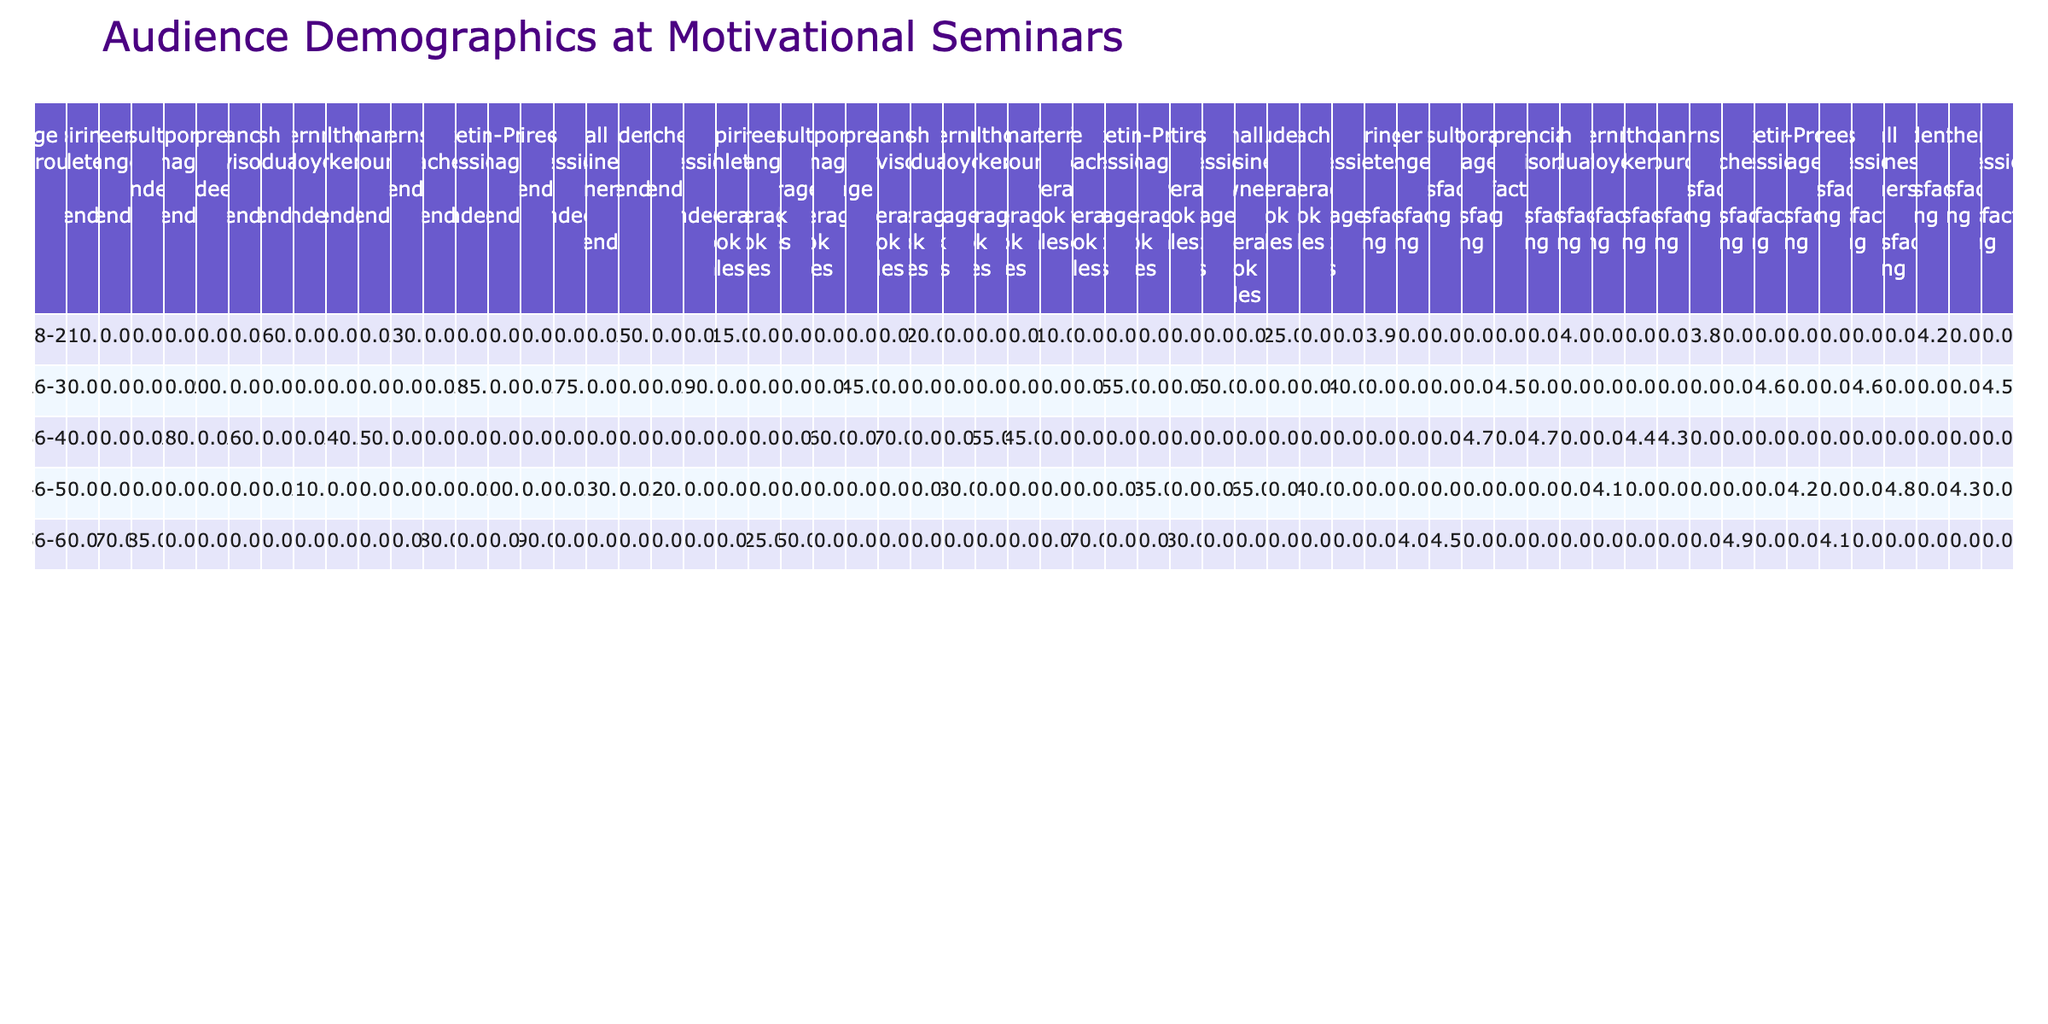What is the satisfaction rating of Corporate Managers? The table shows that Corporate Managers have a satisfaction rating of 4.7.
Answer: 4.7 Which age group has the highest average book sales? Looking at the average book sales for each age group, the 46-55 age group has the highest average book sales at 65.
Answer: 46-55 How many attendees were there for Entrepreneurs in San Francisco? The table indicates that there were 200 attendees for Entrepreneurs in San Francisco.
Answer: 200 Is the average book sales for Tech Professionals higher than that of Life Coaches? Tech Professionals have an average book sales of 40 while Life Coaches have 70. Since 40 is less than 70, the answer is no.
Answer: No What is the total number of attendees for the 26-35 age group across all professions? Adding the attendees: 200 (Entrepreneurs) + 175 (Sales Professionals) + 190 (Tech Professionals) + 185 (Marketing Professionals) = 750 attendees total for the 26-35 age group.
Answer: 750 What is the average satisfaction rating of the 56-65 age group? The average satisfaction rating can be calculated as follows: (4.1 + 4.9 + 4.0 + 4.5) / 4 = 4.375.
Answer: 4.375 Which profession in the 18-25 age group has the highest satisfaction rating? The satisfaction ratings for the 18-25 age group are: Students (4.2), Fresh Graduates (4.0), Aspiring Athletes (3.9), and Interns (3.8). The highest is 4.2 for Students.
Answer: Students What is the difference in average book sales between Corporate Managers and Non-Profit Managers? Corporate Managers have average book sales of 60, while Non-Profit Managers have 35. The difference is 60 - 35 = 25.
Answer: 25 What age group has the lowest number of attendees? By checking the attendee numbers, the 56-65 age group has the lowest with only 90 attendees from Retirees.
Answer: 56-65 